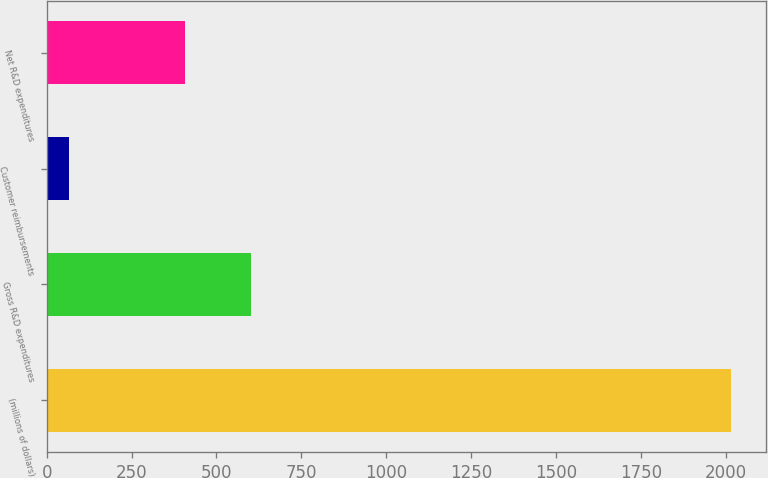Convert chart to OTSL. <chart><loc_0><loc_0><loc_500><loc_500><bar_chart><fcel>(millions of dollars)<fcel>Gross R&D expenditures<fcel>Customer reimbursements<fcel>Net R&D expenditures<nl><fcel>2017<fcel>602.64<fcel>65.6<fcel>407.5<nl></chart> 